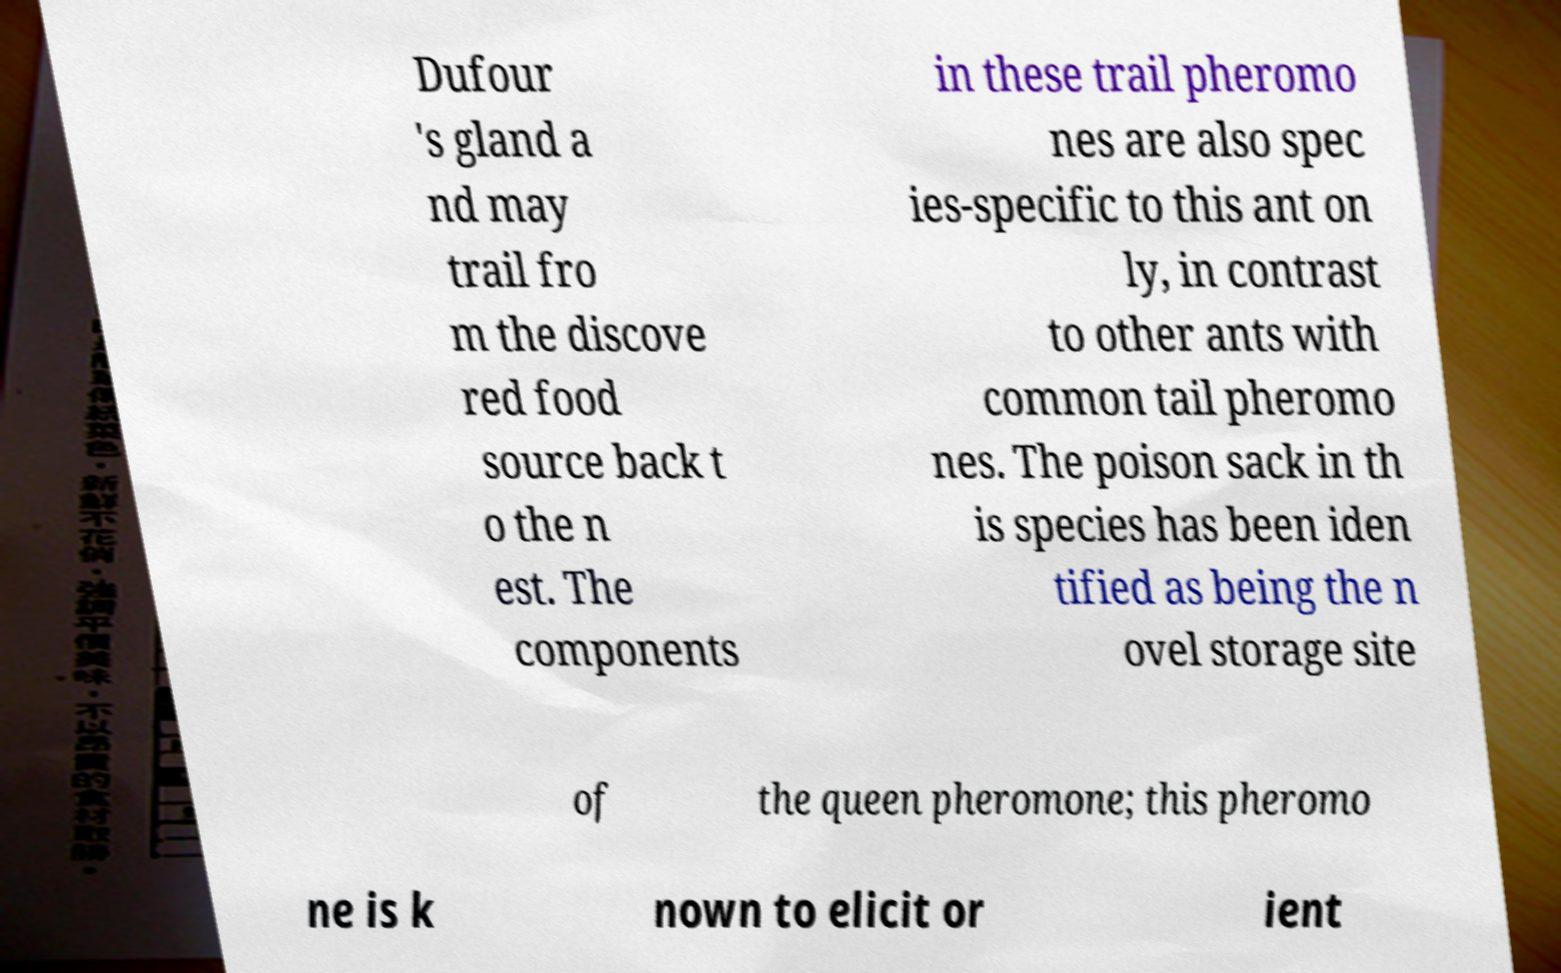For documentation purposes, I need the text within this image transcribed. Could you provide that? Dufour 's gland a nd may trail fro m the discove red food source back t o the n est. The components in these trail pheromo nes are also spec ies-specific to this ant on ly, in contrast to other ants with common tail pheromo nes. The poison sack in th is species has been iden tified as being the n ovel storage site of the queen pheromone; this pheromo ne is k nown to elicit or ient 